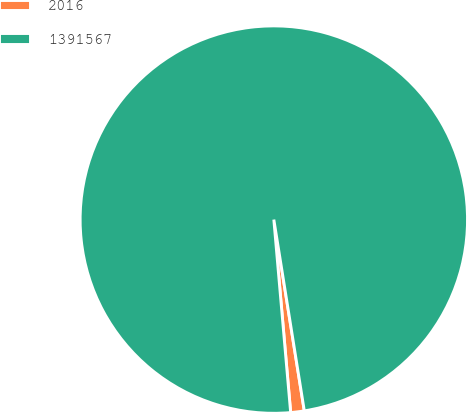<chart> <loc_0><loc_0><loc_500><loc_500><pie_chart><fcel>2016<fcel>1391567<nl><fcel>1.13%<fcel>98.87%<nl></chart> 